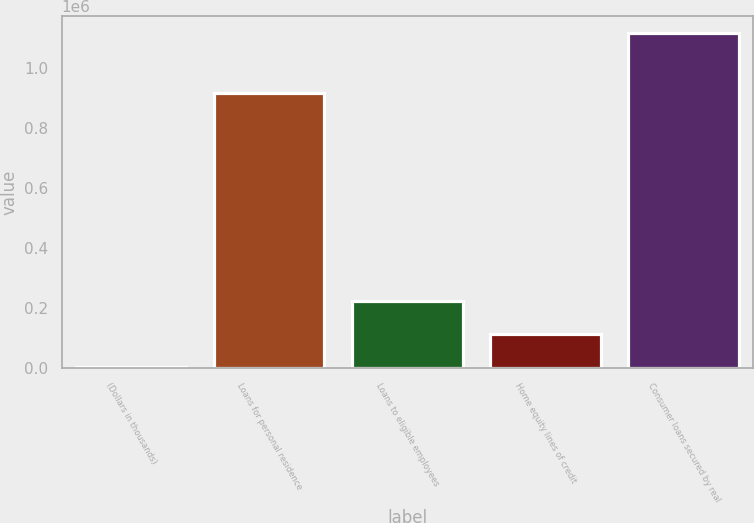Convert chart. <chart><loc_0><loc_0><loc_500><loc_500><bar_chart><fcel>(Dollars in thousands)<fcel>Loans for personal residence<fcel>Loans to eligible employees<fcel>Home equity lines of credit<fcel>Consumer loans secured by real<nl><fcel>2014<fcel>918629<fcel>225234<fcel>113624<fcel>1.11812e+06<nl></chart> 